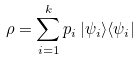<formula> <loc_0><loc_0><loc_500><loc_500>\rho = \sum _ { i = 1 } ^ { k } p _ { i } \, | \psi _ { i } \rangle \langle \psi _ { i } |</formula> 